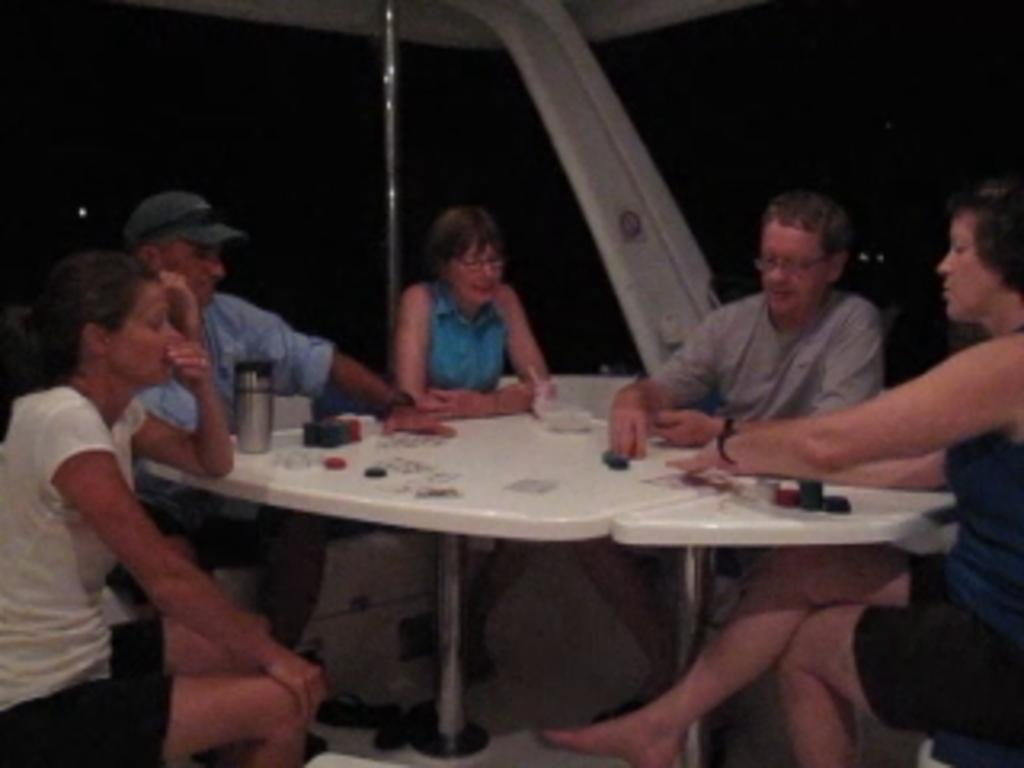How many people are in the image? There are five people in the image. What are the people doing in the image? The people are sitting at a round table. What objects can be seen on the table? There are packs of cards on the table. Where was the image taken? The image was taken inside a boat. How many visitors can be seen in the wilderness in the image? There are no visitors or wilderness present in the image; it features five people sitting at a round table inside a boat. 